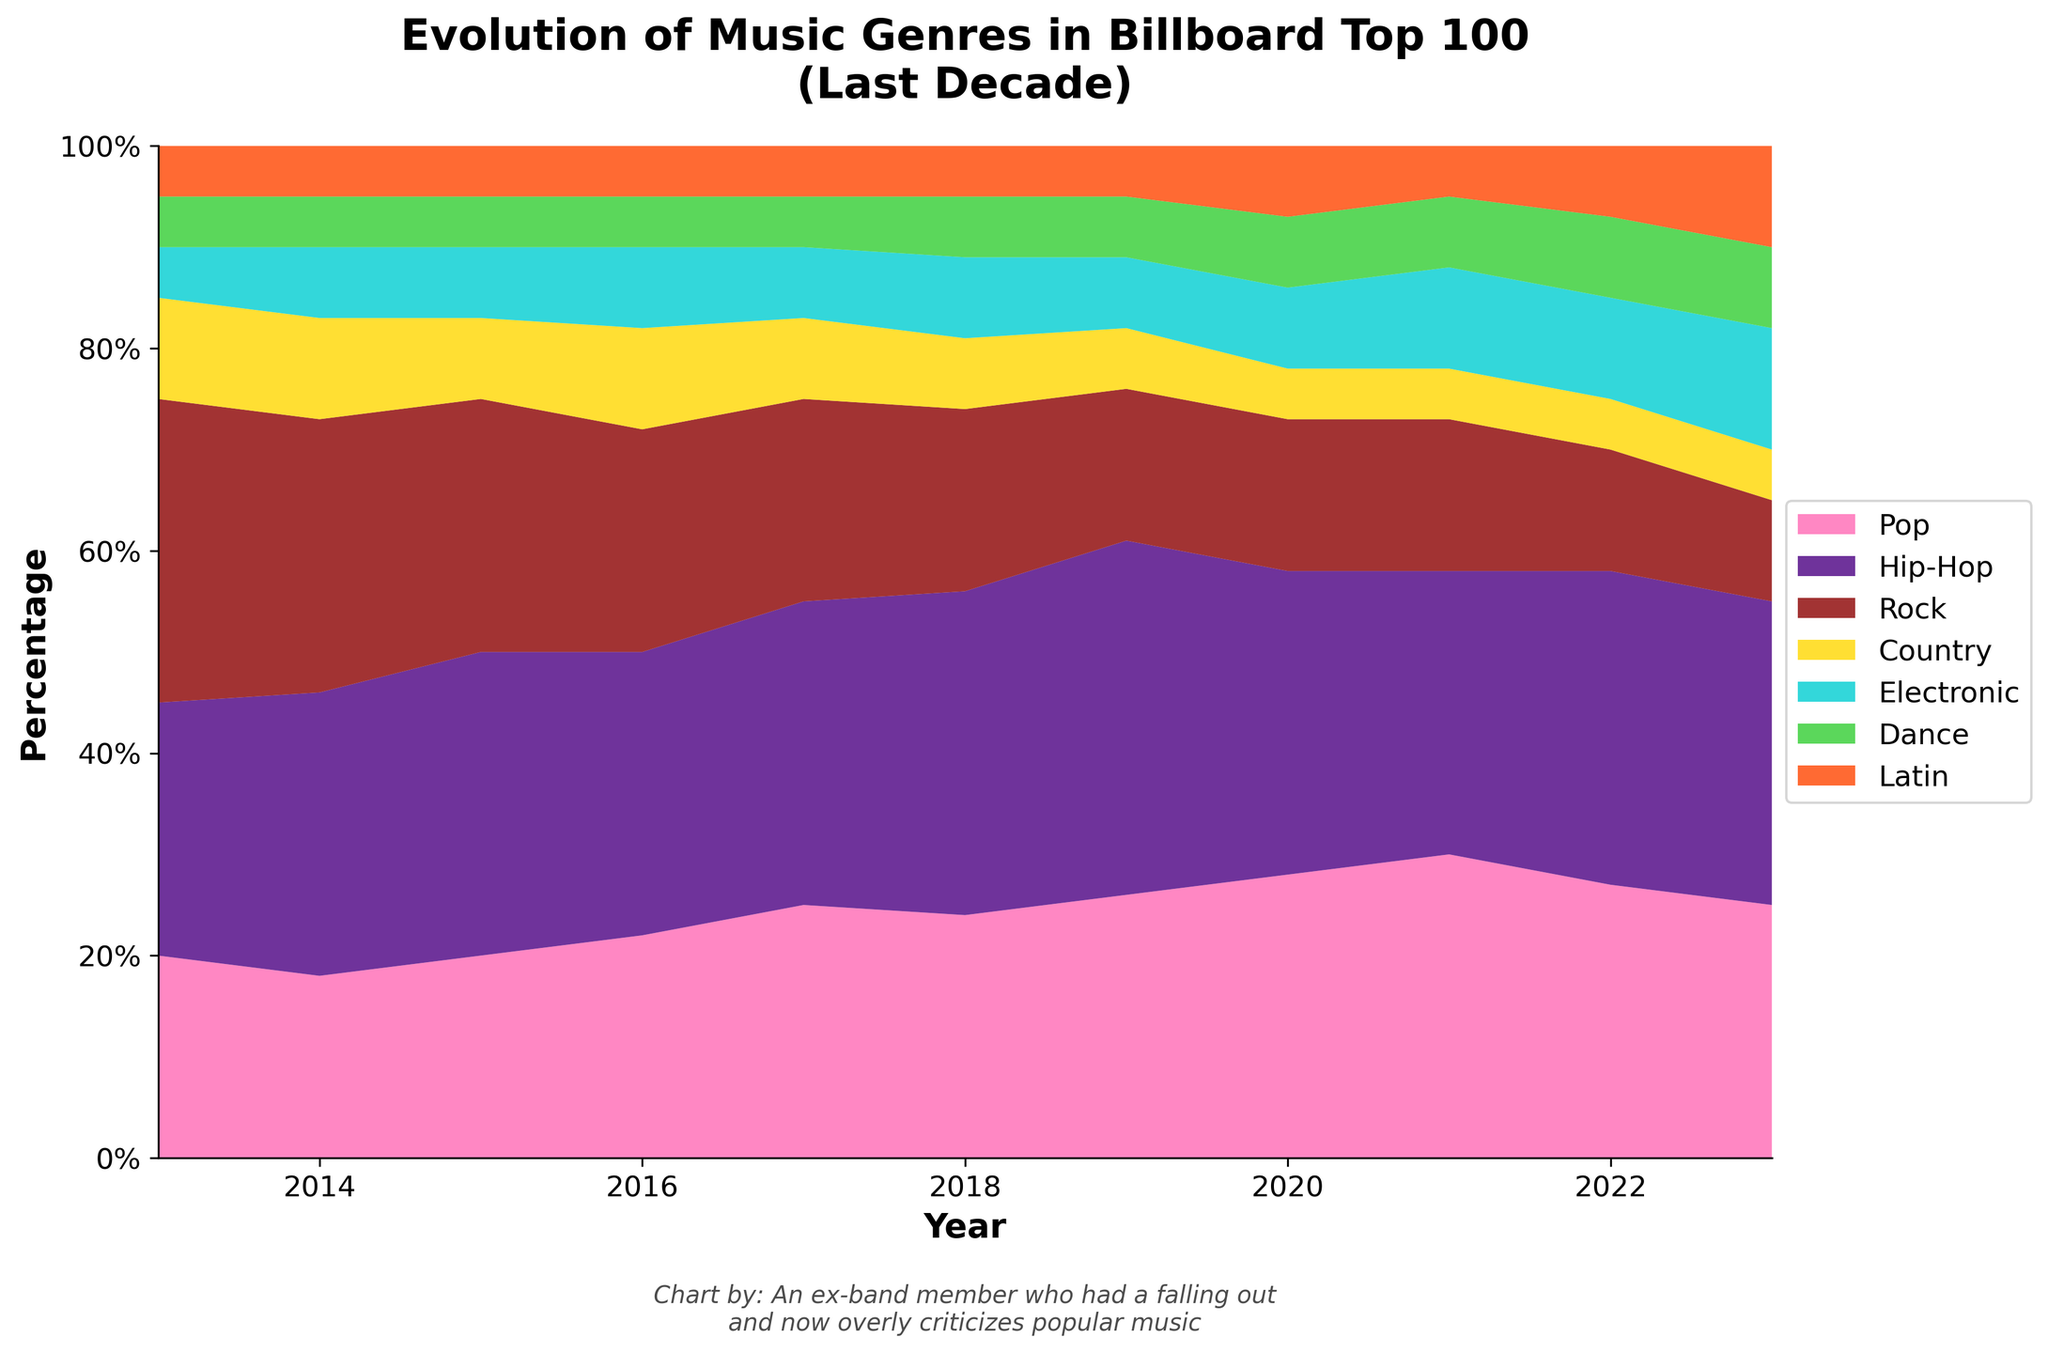What is the title of the figure? The title of the figure is found at the top and usually describes the content of the chart. Here, it reads "Evolution of Music Genres in Billboard Top 100 (Last Decade)".
Answer: Evolution of Music Genres in Billboard Top 100 (Last Decade) What is the y-axis label? The y-axis label is identified on the vertical axis and describes what the percentages represent. Here, it reads "Percentage".
Answer: Percentage How many genres are represented in the chart? The number of areas/colors representing different genres can be counted in the legend or directly on the chart. There are 7 distinct genres shown.
Answer: 7 What was the combined percentage of Pop and Hip-Hop in 2019? Add the percentages of the two genres in 2019: Pop (26%) + Hip-Hop (35%) = 61%.
Answer: 61% Between which years did the percentage of Electronic music increase the most? By calculating the difference for each year and comparing them, we notice the biggest increase happens between 2022 and 2023: from 10% to 12%.
Answer: 2022-2023 Which genre had the highest percentage in 2020? Looking at the chart for the year 2020, Hip-Hop had the highest percentage at 30%.
Answer: Hip-Hop Did the percentage of Rock increase or decrease from 2013 to 2023? Comparing the chart areas for 2013 (30%) and 2023 (10%), it is clear that Rock decreased.
Answer: Decreased Which genre showed the most consistent percentage (least variation) over the decade? Examining the chart, Dance music consistently hovers around 5-8%, showing minimal changes.
Answer: Dance In which year did Latin music see its highest percentage? By looking at the chart area for Latin music across all years, 2023 has the largest area corresponding to Latin music at 10%.
Answer: 2023 